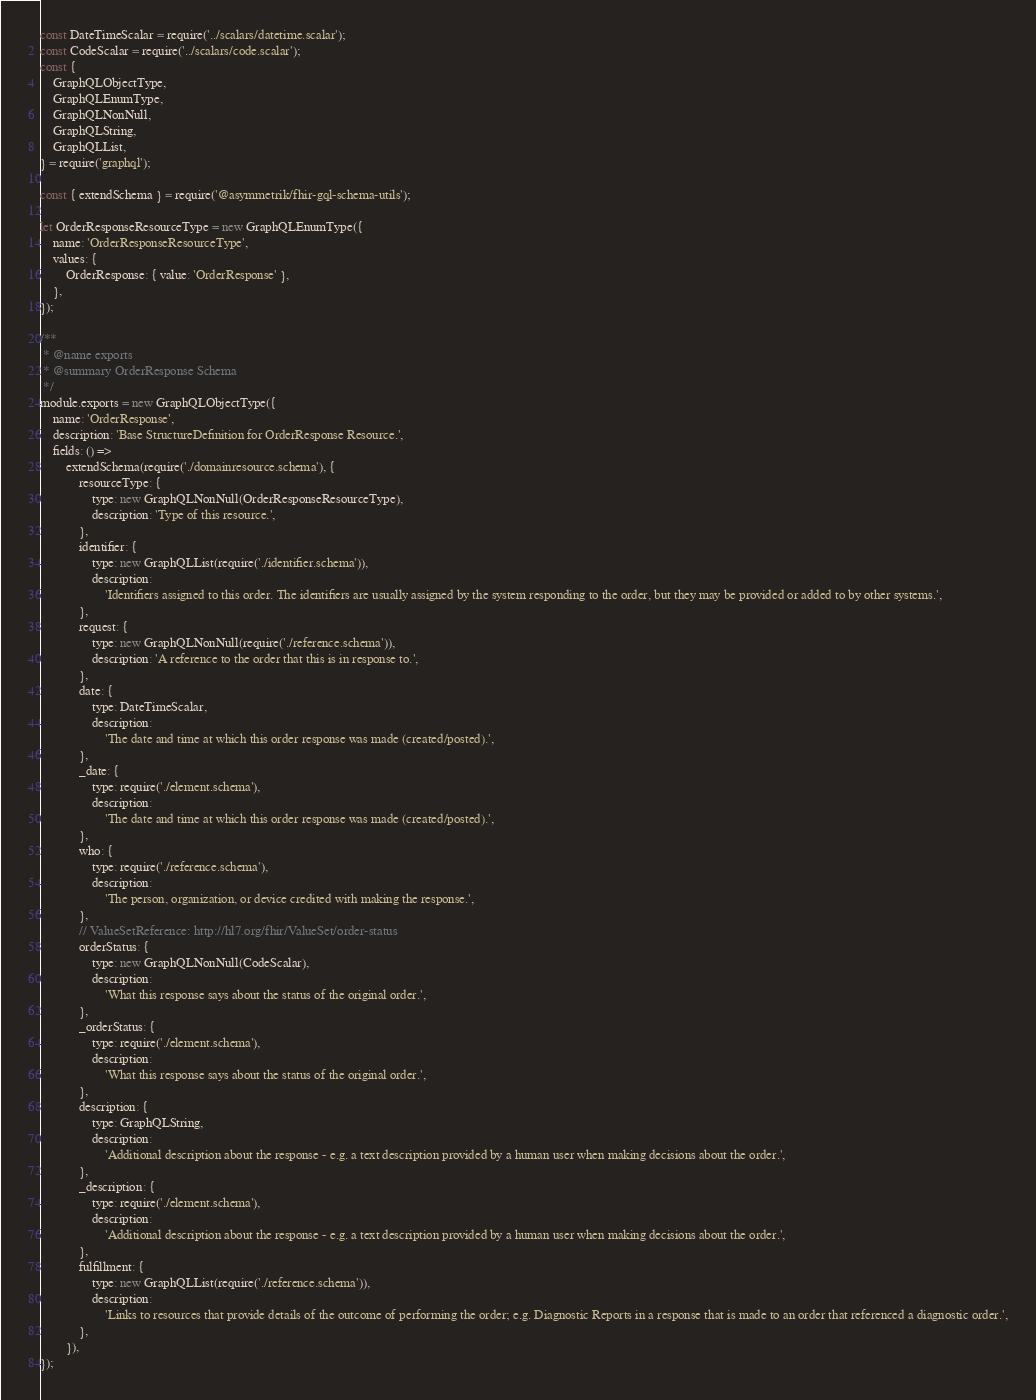<code> <loc_0><loc_0><loc_500><loc_500><_JavaScript_>const DateTimeScalar = require('../scalars/datetime.scalar');
const CodeScalar = require('../scalars/code.scalar');
const {
	GraphQLObjectType,
	GraphQLEnumType,
	GraphQLNonNull,
	GraphQLString,
	GraphQLList,
} = require('graphql');

const { extendSchema } = require('@asymmetrik/fhir-gql-schema-utils');

let OrderResponseResourceType = new GraphQLEnumType({
	name: 'OrderResponseResourceType',
	values: {
		OrderResponse: { value: 'OrderResponse' },
	},
});

/**
 * @name exports
 * @summary OrderResponse Schema
 */
module.exports = new GraphQLObjectType({
	name: 'OrderResponse',
	description: 'Base StructureDefinition for OrderResponse Resource.',
	fields: () =>
		extendSchema(require('./domainresource.schema'), {
			resourceType: {
				type: new GraphQLNonNull(OrderResponseResourceType),
				description: 'Type of this resource.',
			},
			identifier: {
				type: new GraphQLList(require('./identifier.schema')),
				description:
					'Identifiers assigned to this order. The identifiers are usually assigned by the system responding to the order, but they may be provided or added to by other systems.',
			},
			request: {
				type: new GraphQLNonNull(require('./reference.schema')),
				description: 'A reference to the order that this is in response to.',
			},
			date: {
				type: DateTimeScalar,
				description:
					'The date and time at which this order response was made (created/posted).',
			},
			_date: {
				type: require('./element.schema'),
				description:
					'The date and time at which this order response was made (created/posted).',
			},
			who: {
				type: require('./reference.schema'),
				description:
					'The person, organization, or device credited with making the response.',
			},
			// ValueSetReference: http://hl7.org/fhir/ValueSet/order-status
			orderStatus: {
				type: new GraphQLNonNull(CodeScalar),
				description:
					'What this response says about the status of the original order.',
			},
			_orderStatus: {
				type: require('./element.schema'),
				description:
					'What this response says about the status of the original order.',
			},
			description: {
				type: GraphQLString,
				description:
					'Additional description about the response - e.g. a text description provided by a human user when making decisions about the order.',
			},
			_description: {
				type: require('./element.schema'),
				description:
					'Additional description about the response - e.g. a text description provided by a human user when making decisions about the order.',
			},
			fulfillment: {
				type: new GraphQLList(require('./reference.schema')),
				description:
					'Links to resources that provide details of the outcome of performing the order; e.g. Diagnostic Reports in a response that is made to an order that referenced a diagnostic order.',
			},
		}),
});
</code> 